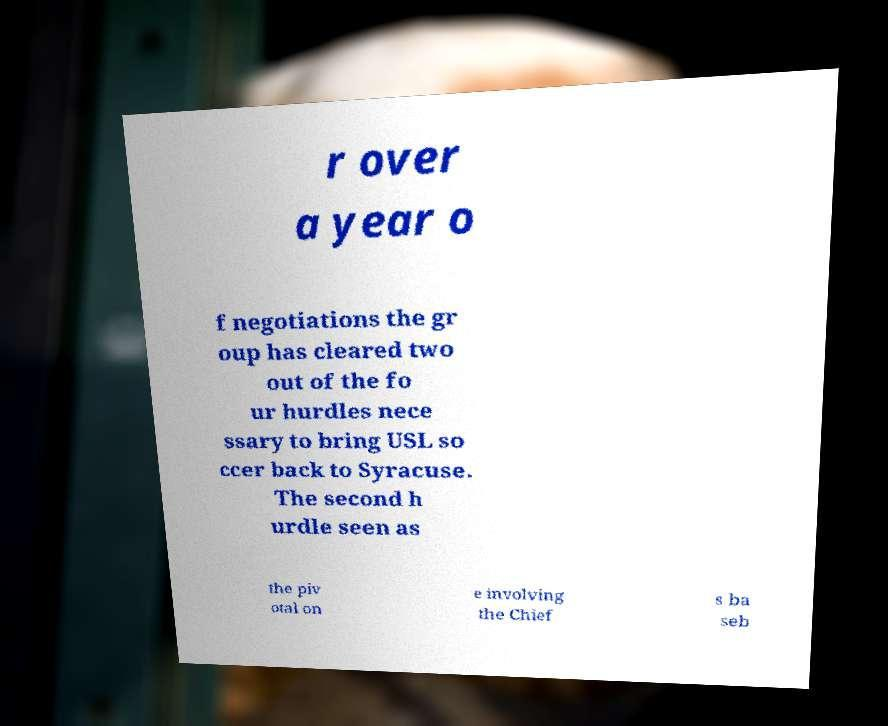What messages or text are displayed in this image? I need them in a readable, typed format. r over a year o f negotiations the gr oup has cleared two out of the fo ur hurdles nece ssary to bring USL so ccer back to Syracuse. The second h urdle seen as the piv otal on e involving the Chief s ba seb 